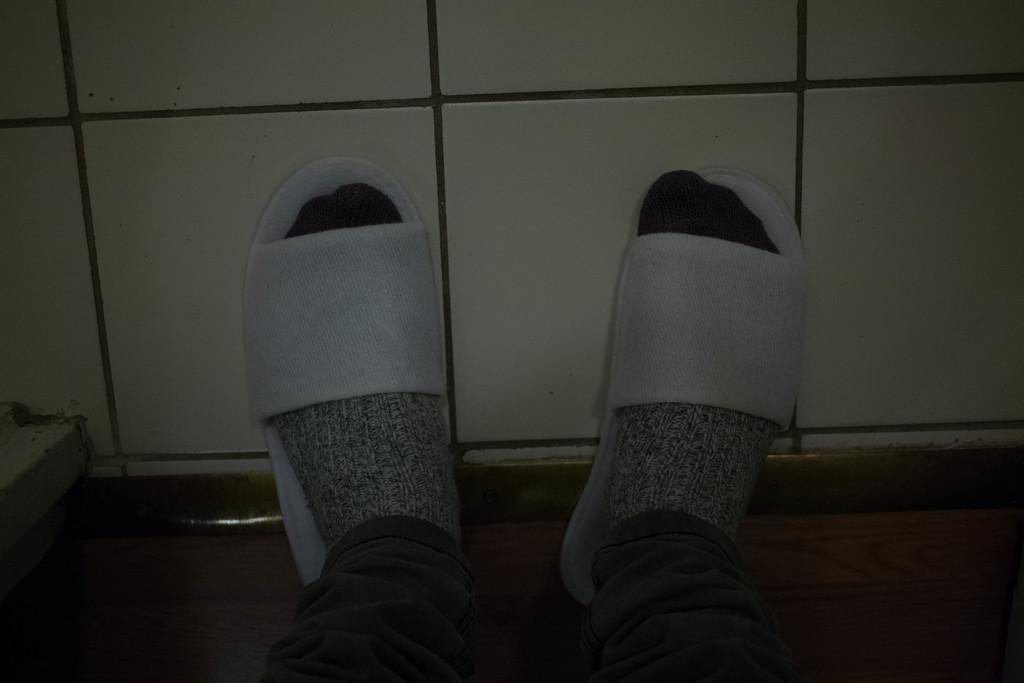What is present in the image? There is a person in the image. What part of the person's body can be seen? The person's legs are visible. What type of footwear is the person wearing? The person is wearing white color slippers. Are there any additional clothing items visible? Yes, the person is wearing socks. What is the color of the background in the image? The background of the image is white. What type of nut can be seen falling from the person's hair in the image? There is no nut present in the image, nor is there any indication that the person has a nut in their hair. 